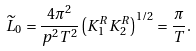Convert formula to latex. <formula><loc_0><loc_0><loc_500><loc_500>\widetilde { L } _ { 0 } = \frac { 4 \pi ^ { 2 } } { p ^ { 2 } T ^ { 2 } } \left ( K _ { 1 } ^ { R } K _ { 2 } ^ { R } \right ) ^ { 1 / 2 } = \frac { \pi } { T } .</formula> 